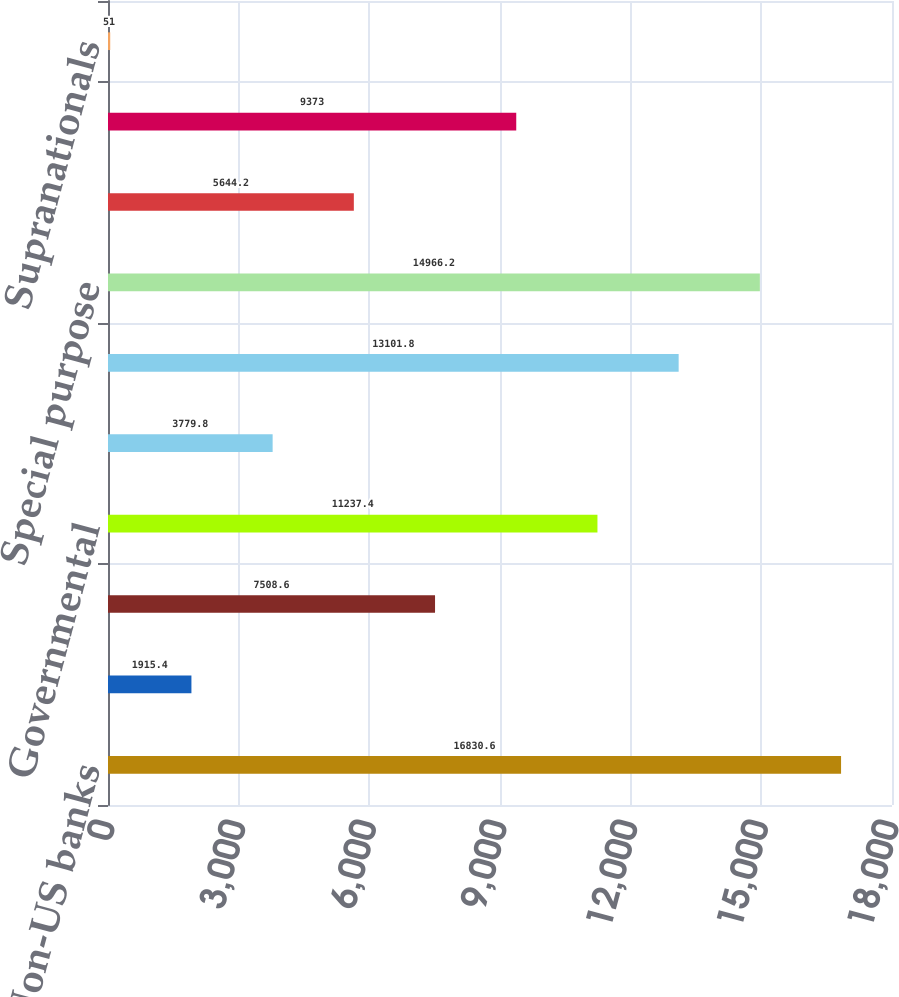Convert chart. <chart><loc_0><loc_0><loc_500><loc_500><bar_chart><fcel>Non-US banks<fcel>Insured municipalities<fcel>US industrials<fcel>Governmental<fcel>Non-US financial service<fcel>Non-US industrials<fcel>Special purpose<fcel>US banks<fcel>US financial service companies<fcel>Supranationals<nl><fcel>16830.6<fcel>1915.4<fcel>7508.6<fcel>11237.4<fcel>3779.8<fcel>13101.8<fcel>14966.2<fcel>5644.2<fcel>9373<fcel>51<nl></chart> 